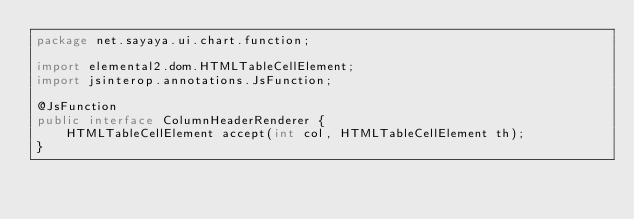Convert code to text. <code><loc_0><loc_0><loc_500><loc_500><_Java_>package net.sayaya.ui.chart.function;

import elemental2.dom.HTMLTableCellElement;
import jsinterop.annotations.JsFunction;

@JsFunction
public interface ColumnHeaderRenderer {
	HTMLTableCellElement accept(int col, HTMLTableCellElement th);
}
</code> 